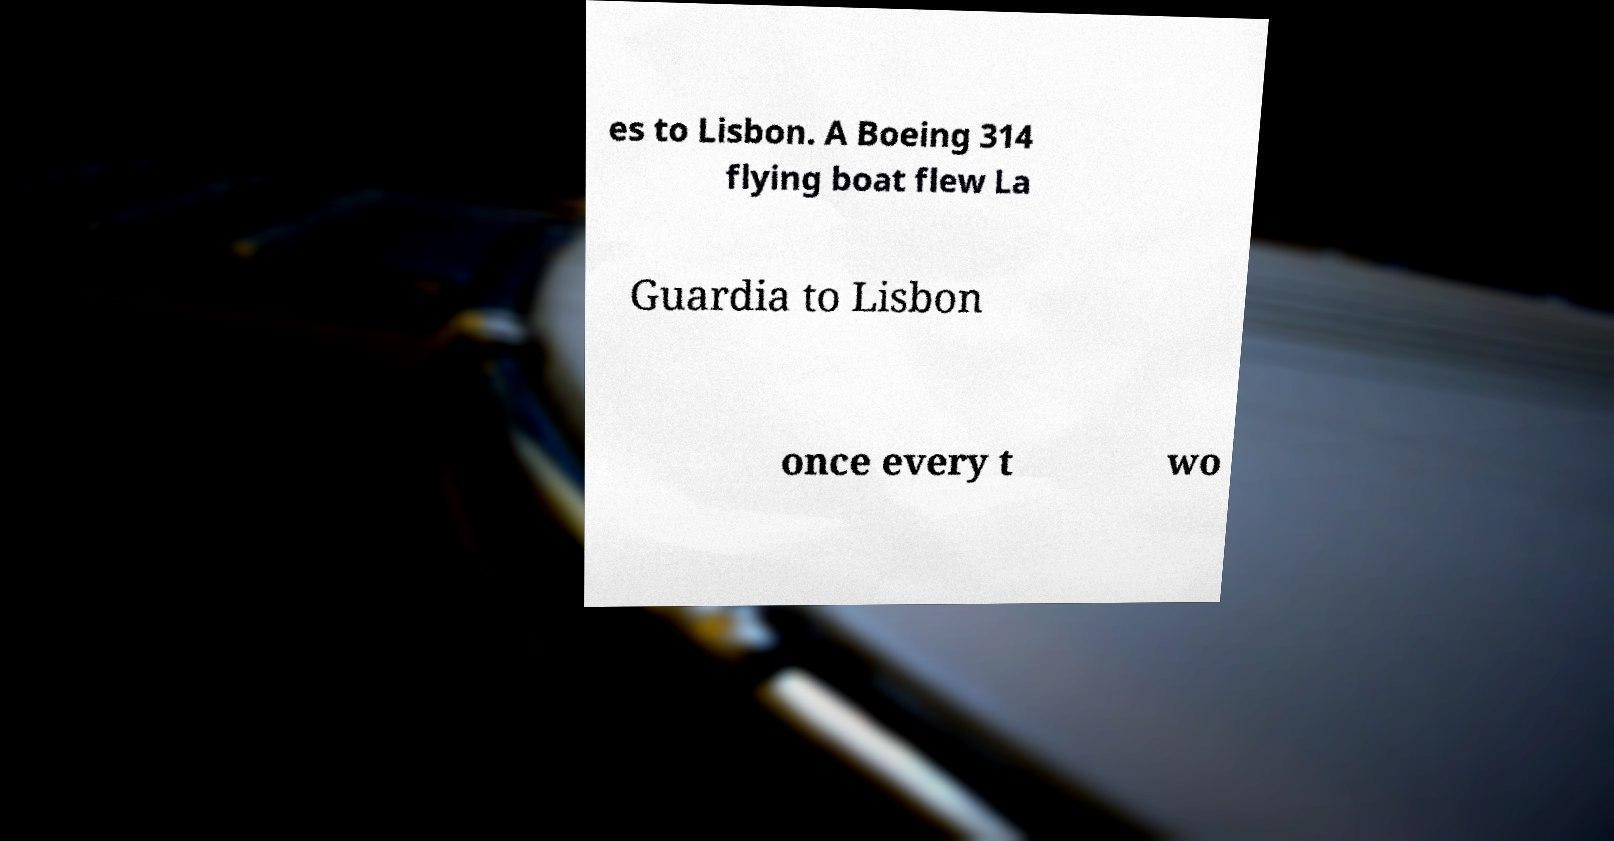Please identify and transcribe the text found in this image. es to Lisbon. A Boeing 314 flying boat flew La Guardia to Lisbon once every t wo 